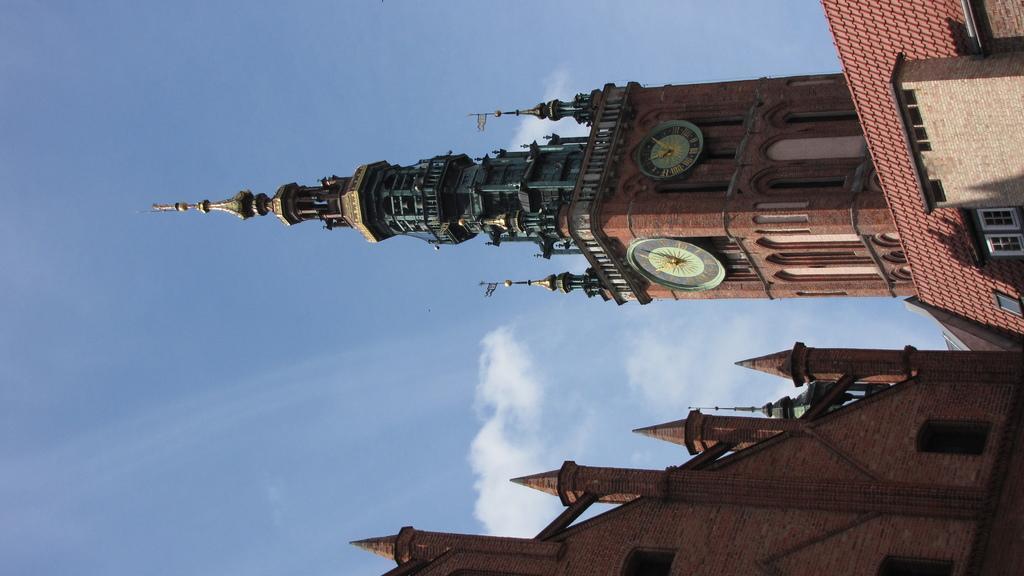In one or two sentences, can you explain what this image depicts? We can see buildings, windows and we can see clocks in this building. In the background we can see sky with clouds. 